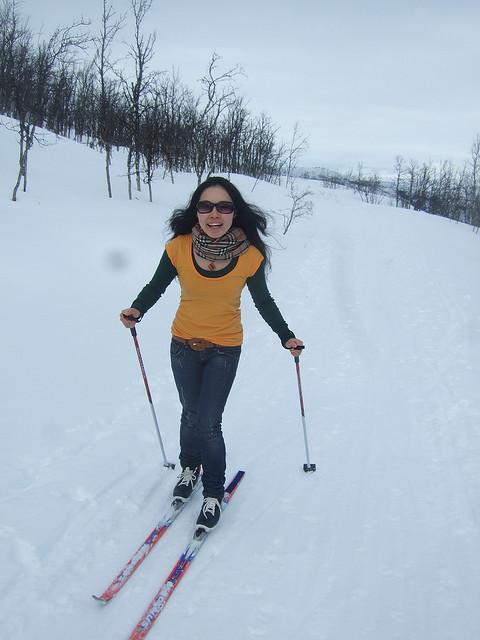How many white birds are there?
Give a very brief answer. 0. 